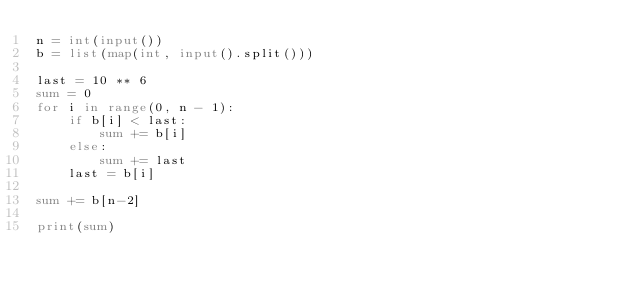Convert code to text. <code><loc_0><loc_0><loc_500><loc_500><_Python_>n = int(input())
b = list(map(int, input().split()))

last = 10 ** 6
sum = 0
for i in range(0, n - 1):
    if b[i] < last:
        sum += b[i]
    else:
        sum += last
    last = b[i]

sum += b[n-2]

print(sum)
</code> 